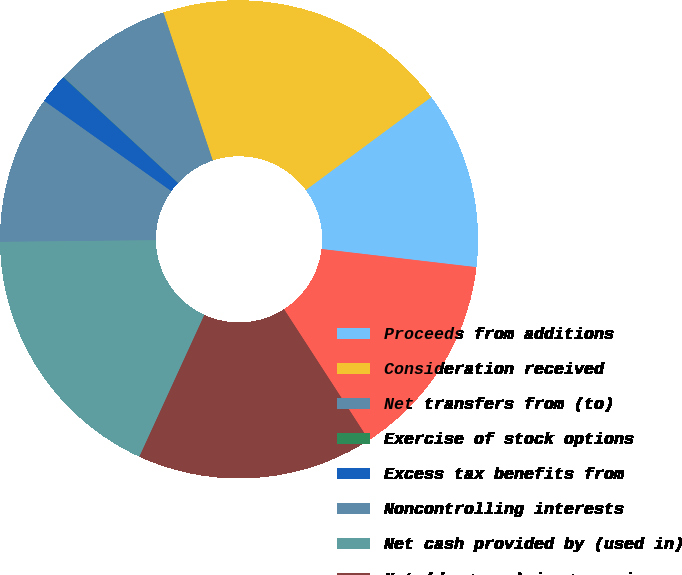<chart> <loc_0><loc_0><loc_500><loc_500><pie_chart><fcel>Proceeds from additions<fcel>Consideration received<fcel>Net transfers from (to)<fcel>Exercise of stock options<fcel>Excess tax benefits from<fcel>Noncontrolling interests<fcel>Net cash provided by (used in)<fcel>Net (decrease) increase in<fcel>Cash and cash equivalents at<nl><fcel>12.0%<fcel>19.98%<fcel>8.01%<fcel>0.02%<fcel>2.02%<fcel>10.0%<fcel>17.99%<fcel>15.99%<fcel>13.99%<nl></chart> 